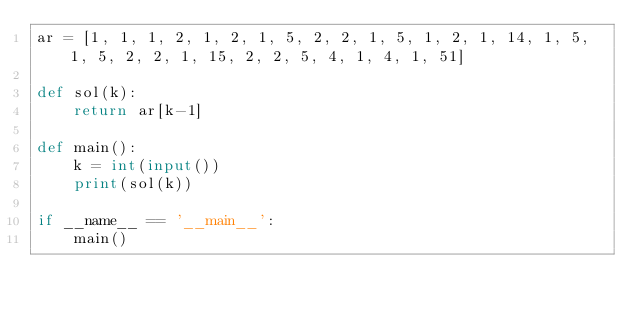Convert code to text. <code><loc_0><loc_0><loc_500><loc_500><_Python_>ar = [1, 1, 1, 2, 1, 2, 1, 5, 2, 2, 1, 5, 1, 2, 1, 14, 1, 5, 1, 5, 2, 2, 1, 15, 2, 2, 5, 4, 1, 4, 1, 51]

def sol(k):
    return ar[k-1]

def main():
    k = int(input())
    print(sol(k))

if __name__ == '__main__':
    main()
</code> 